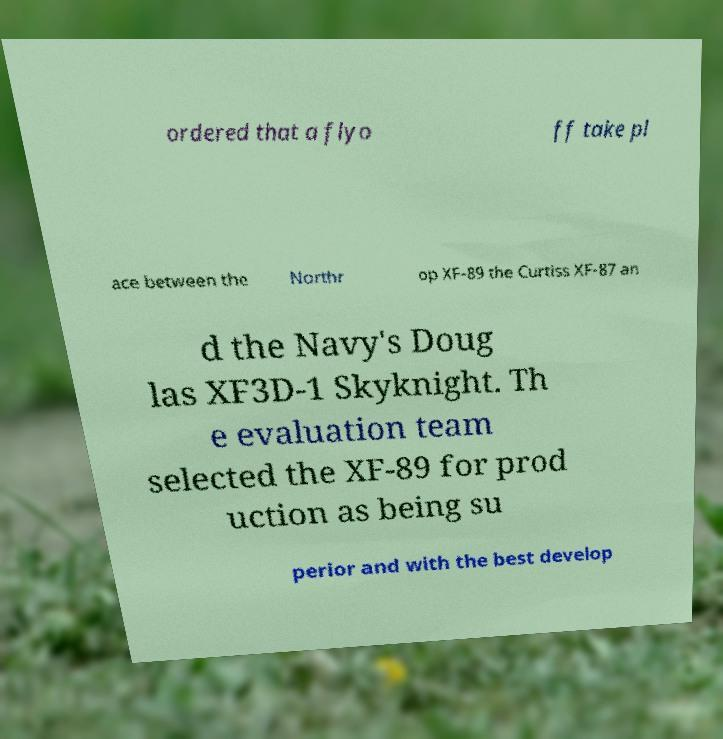Can you read and provide the text displayed in the image?This photo seems to have some interesting text. Can you extract and type it out for me? ordered that a flyo ff take pl ace between the Northr op XF-89 the Curtiss XF-87 an d the Navy's Doug las XF3D-1 Skyknight. Th e evaluation team selected the XF-89 for prod uction as being su perior and with the best develop 